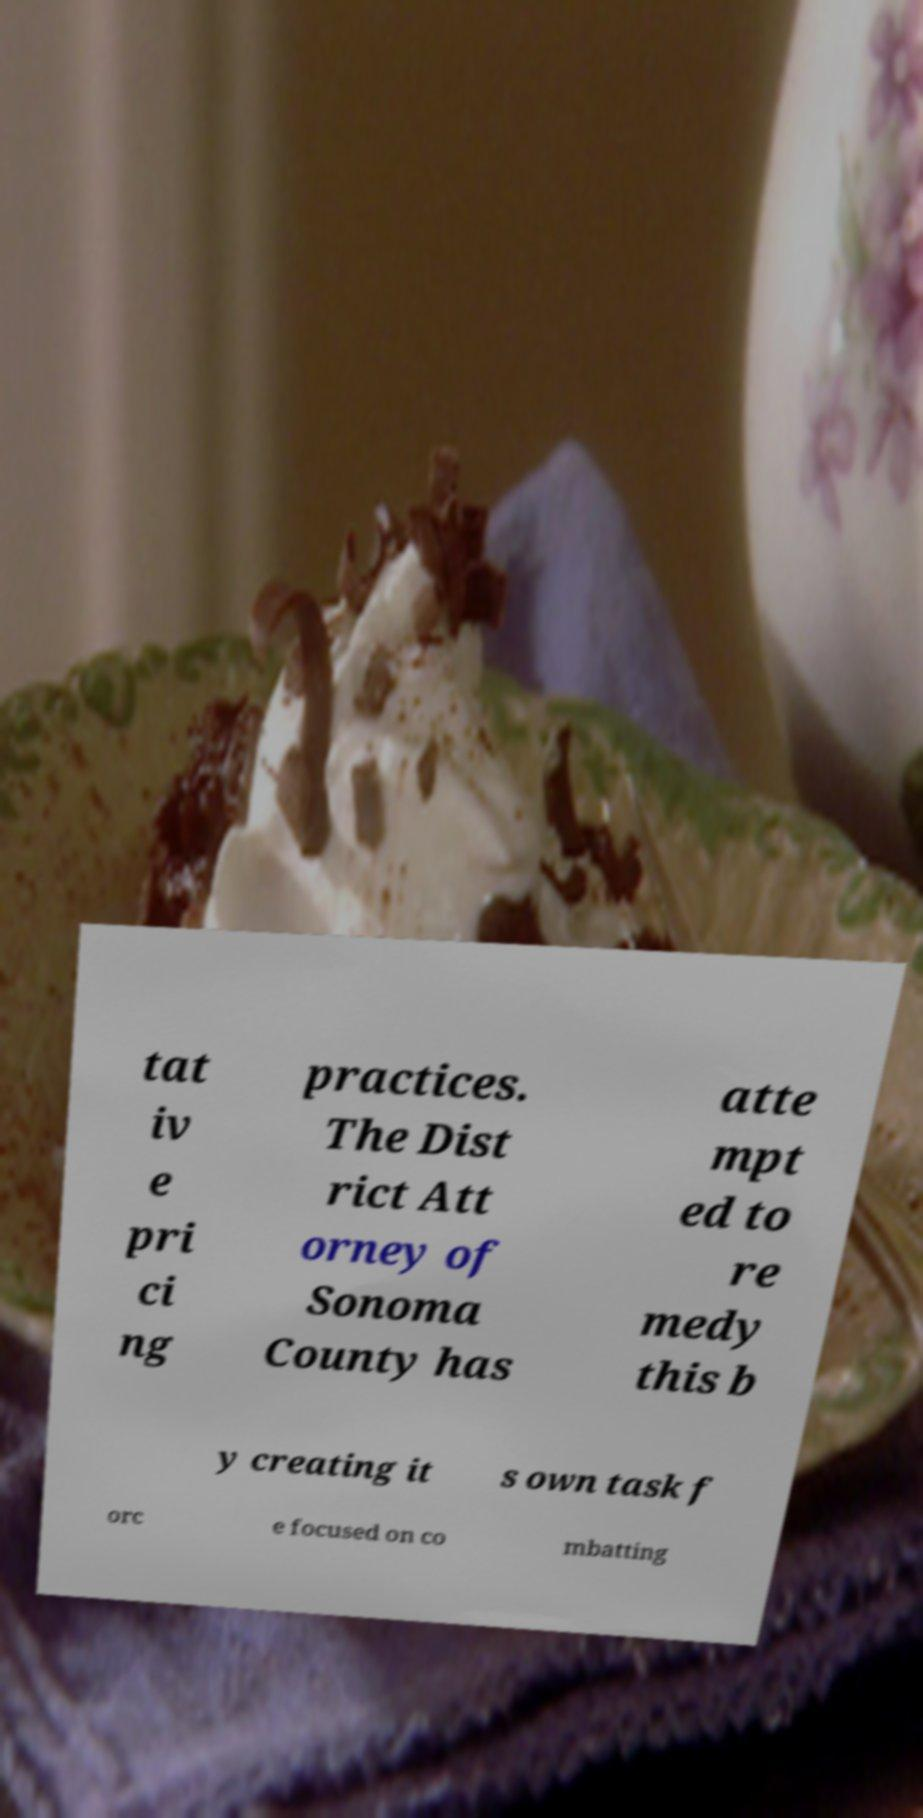There's text embedded in this image that I need extracted. Can you transcribe it verbatim? tat iv e pri ci ng practices. The Dist rict Att orney of Sonoma County has atte mpt ed to re medy this b y creating it s own task f orc e focused on co mbatting 